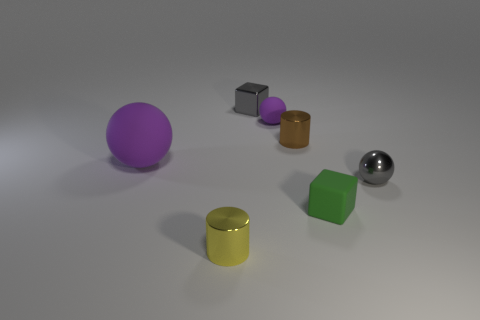Add 1 green matte cubes. How many objects exist? 8 Subtract all balls. How many objects are left? 4 Add 6 tiny gray things. How many tiny gray things exist? 8 Subtract 0 brown blocks. How many objects are left? 7 Subtract all big red metal balls. Subtract all green blocks. How many objects are left? 6 Add 5 metallic objects. How many metallic objects are left? 9 